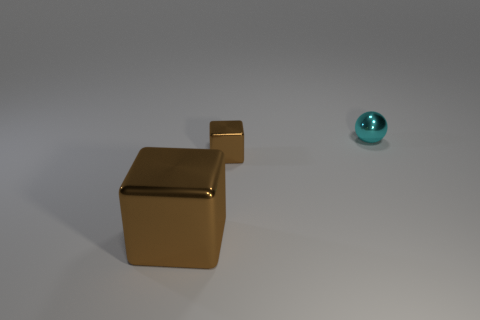What number of other things are there of the same size as the cyan object? There is one other object of the same size as the cyan object, which is the small gold-colored cube. 